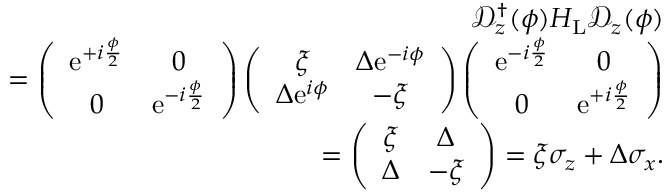<formula> <loc_0><loc_0><loc_500><loc_500>\begin{array} { r l r } & { \mathcal { D } _ { z } ^ { \dagger } ( \phi ) H _ { L } \mathcal { D } _ { z } ( \phi ) } \\ & { = \left ( \begin{array} { c c } { e ^ { + i \frac { \phi } { 2 } } } & { 0 } \\ { 0 } & { e ^ { - i \frac { \phi } { 2 } } } \end{array} \right ) \left ( \begin{array} { c c } { \xi } & { \Delta e ^ { - i \phi } } \\ { \Delta e ^ { i \phi } } & { - \xi } \end{array} \right ) \left ( \begin{array} { c c } { e ^ { - i \frac { \phi } { 2 } } } & { 0 } \\ { 0 } & { e ^ { + i \frac { \phi } { 2 } } } \end{array} \right ) } \\ & { = \left ( \begin{array} { c c } { \xi } & { \Delta } \\ { \Delta } & { - \xi } \end{array} \right ) = \xi \sigma _ { z } + \Delta \sigma _ { x } . } \end{array}</formula> 